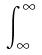<formula> <loc_0><loc_0><loc_500><loc_500>\int _ { \infty } ^ { \infty }</formula> 